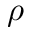<formula> <loc_0><loc_0><loc_500><loc_500>\rho</formula> 